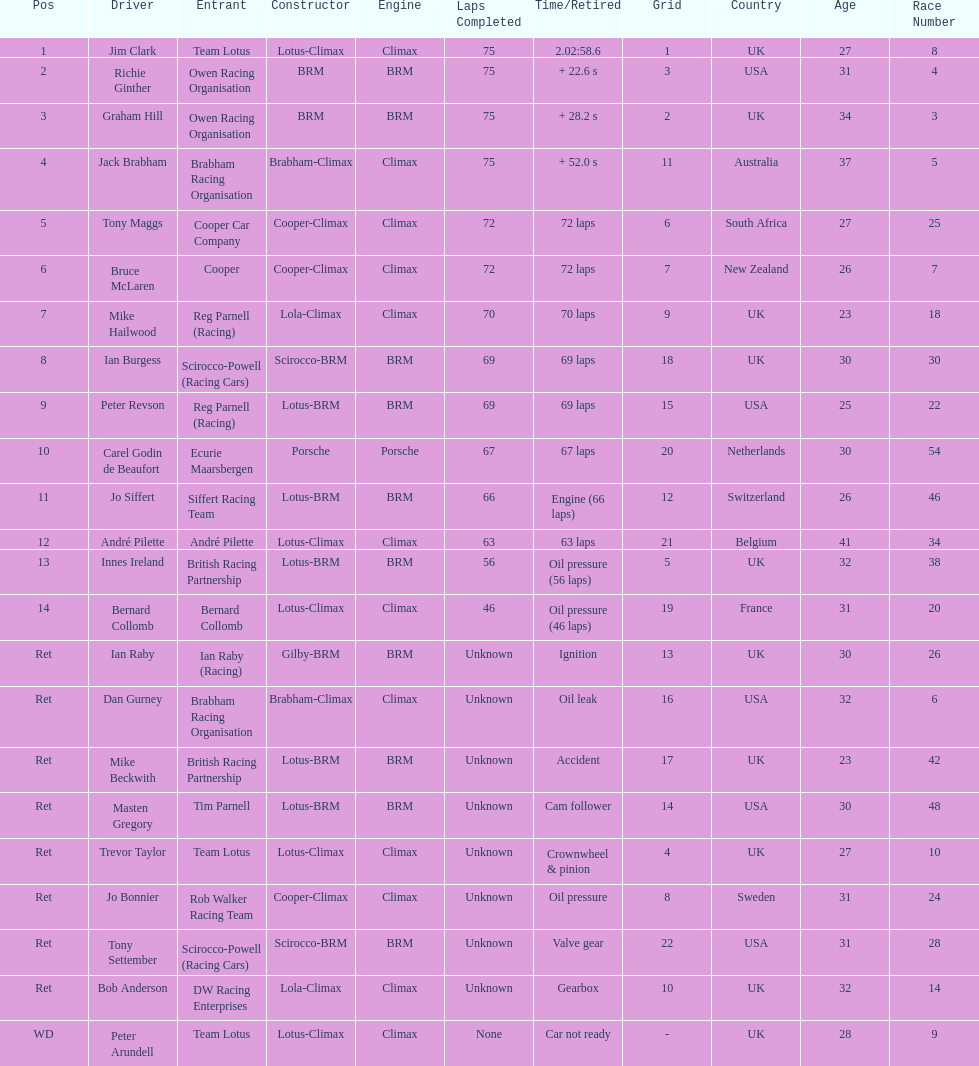Who came in earlier, tony maggs or jo siffert? Tony Maggs. 